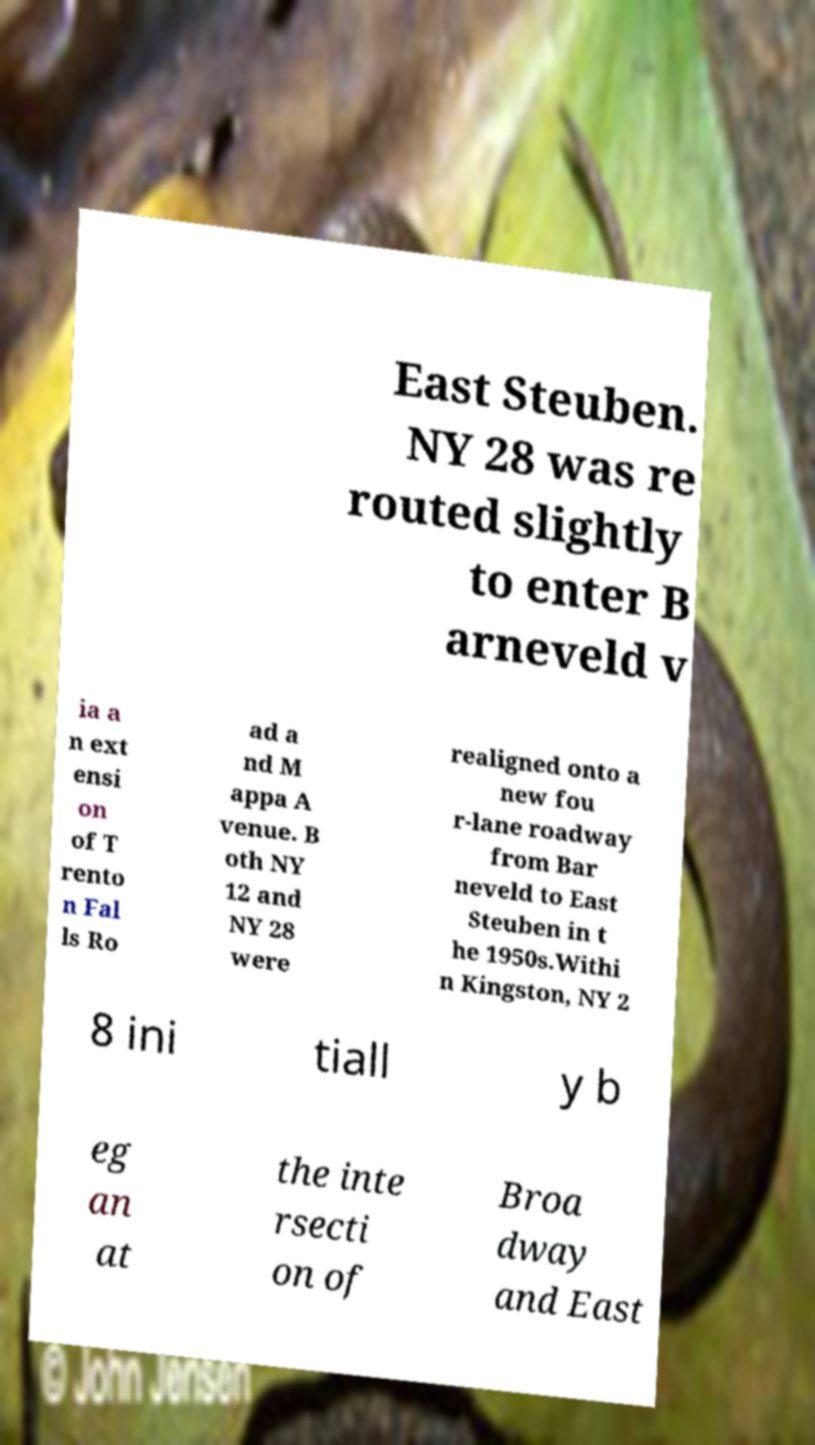Please read and relay the text visible in this image. What does it say? East Steuben. NY 28 was re routed slightly to enter B arneveld v ia a n ext ensi on of T rento n Fal ls Ro ad a nd M appa A venue. B oth NY 12 and NY 28 were realigned onto a new fou r-lane roadway from Bar neveld to East Steuben in t he 1950s.Withi n Kingston, NY 2 8 ini tiall y b eg an at the inte rsecti on of Broa dway and East 